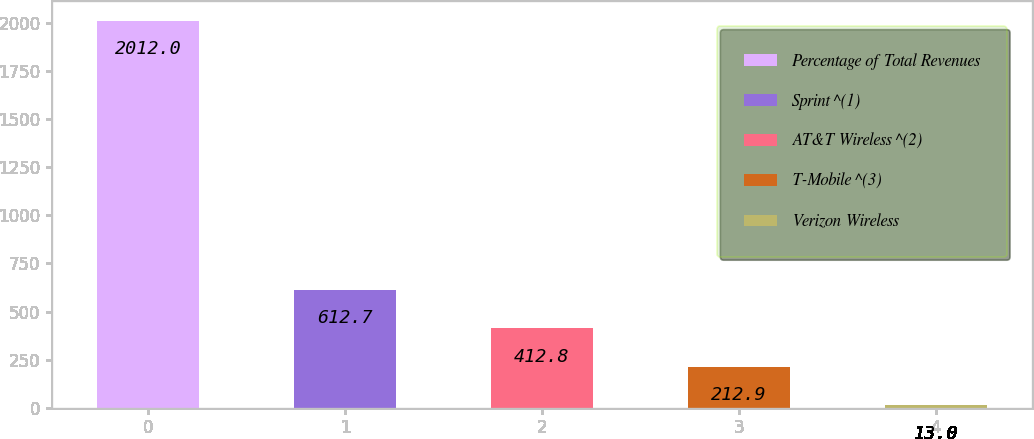Convert chart. <chart><loc_0><loc_0><loc_500><loc_500><bar_chart><fcel>Percentage of Total Revenues<fcel>Sprint ^(1)<fcel>AT&T Wireless ^(2)<fcel>T-Mobile ^(3)<fcel>Verizon Wireless<nl><fcel>2012<fcel>612.7<fcel>412.8<fcel>212.9<fcel>13<nl></chart> 